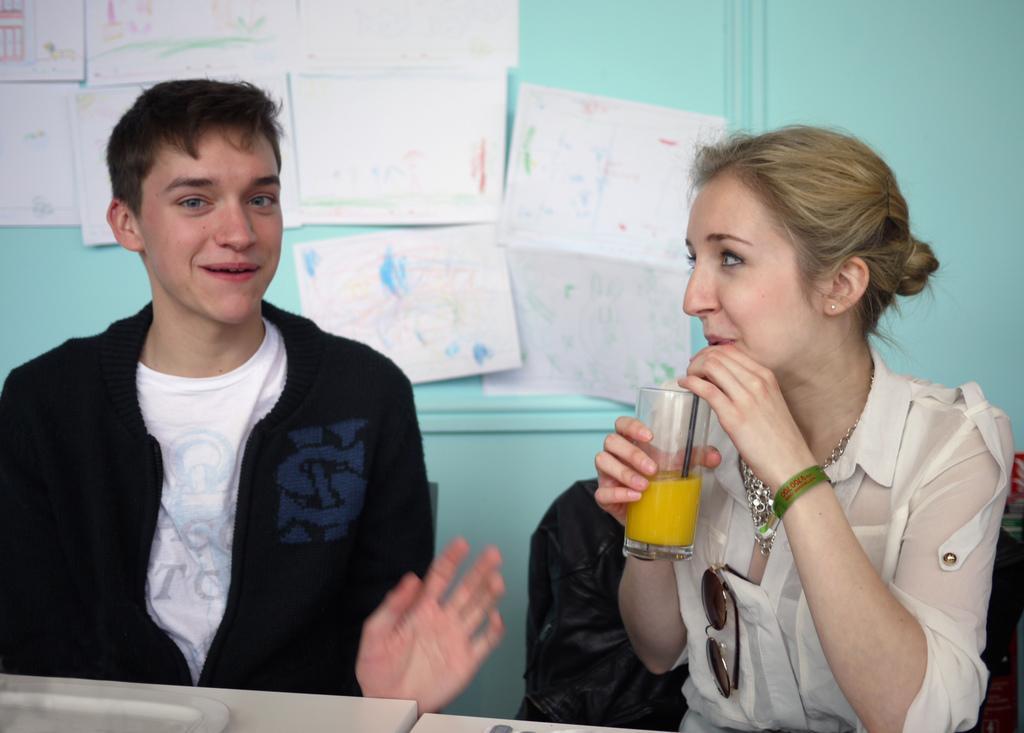In one or two sentences, can you explain what this image depicts? In this image there is a person sitting on the chair. Beside him there is a woman holding a glass in her hand. The glass is filled with the drink. There is a straw in the glass. Before them there is a table having a plate on it. Background there is a wall having few posts attached to it. 